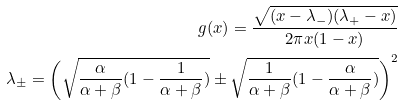<formula> <loc_0><loc_0><loc_500><loc_500>g ( x ) = \frac { \sqrt { ( x - \lambda _ { - } ) ( \lambda _ { + } - x ) } } { 2 \pi x ( 1 - x ) } \\ \lambda _ { \pm } = \left ( \sqrt { \frac { \alpha } { \alpha + \beta } ( 1 - \frac { 1 } { \alpha + \beta } ) } \pm \sqrt { \frac { 1 } { \alpha + \beta } ( 1 - \frac { \alpha } { \alpha + \beta } ) } \right ) ^ { 2 }</formula> 